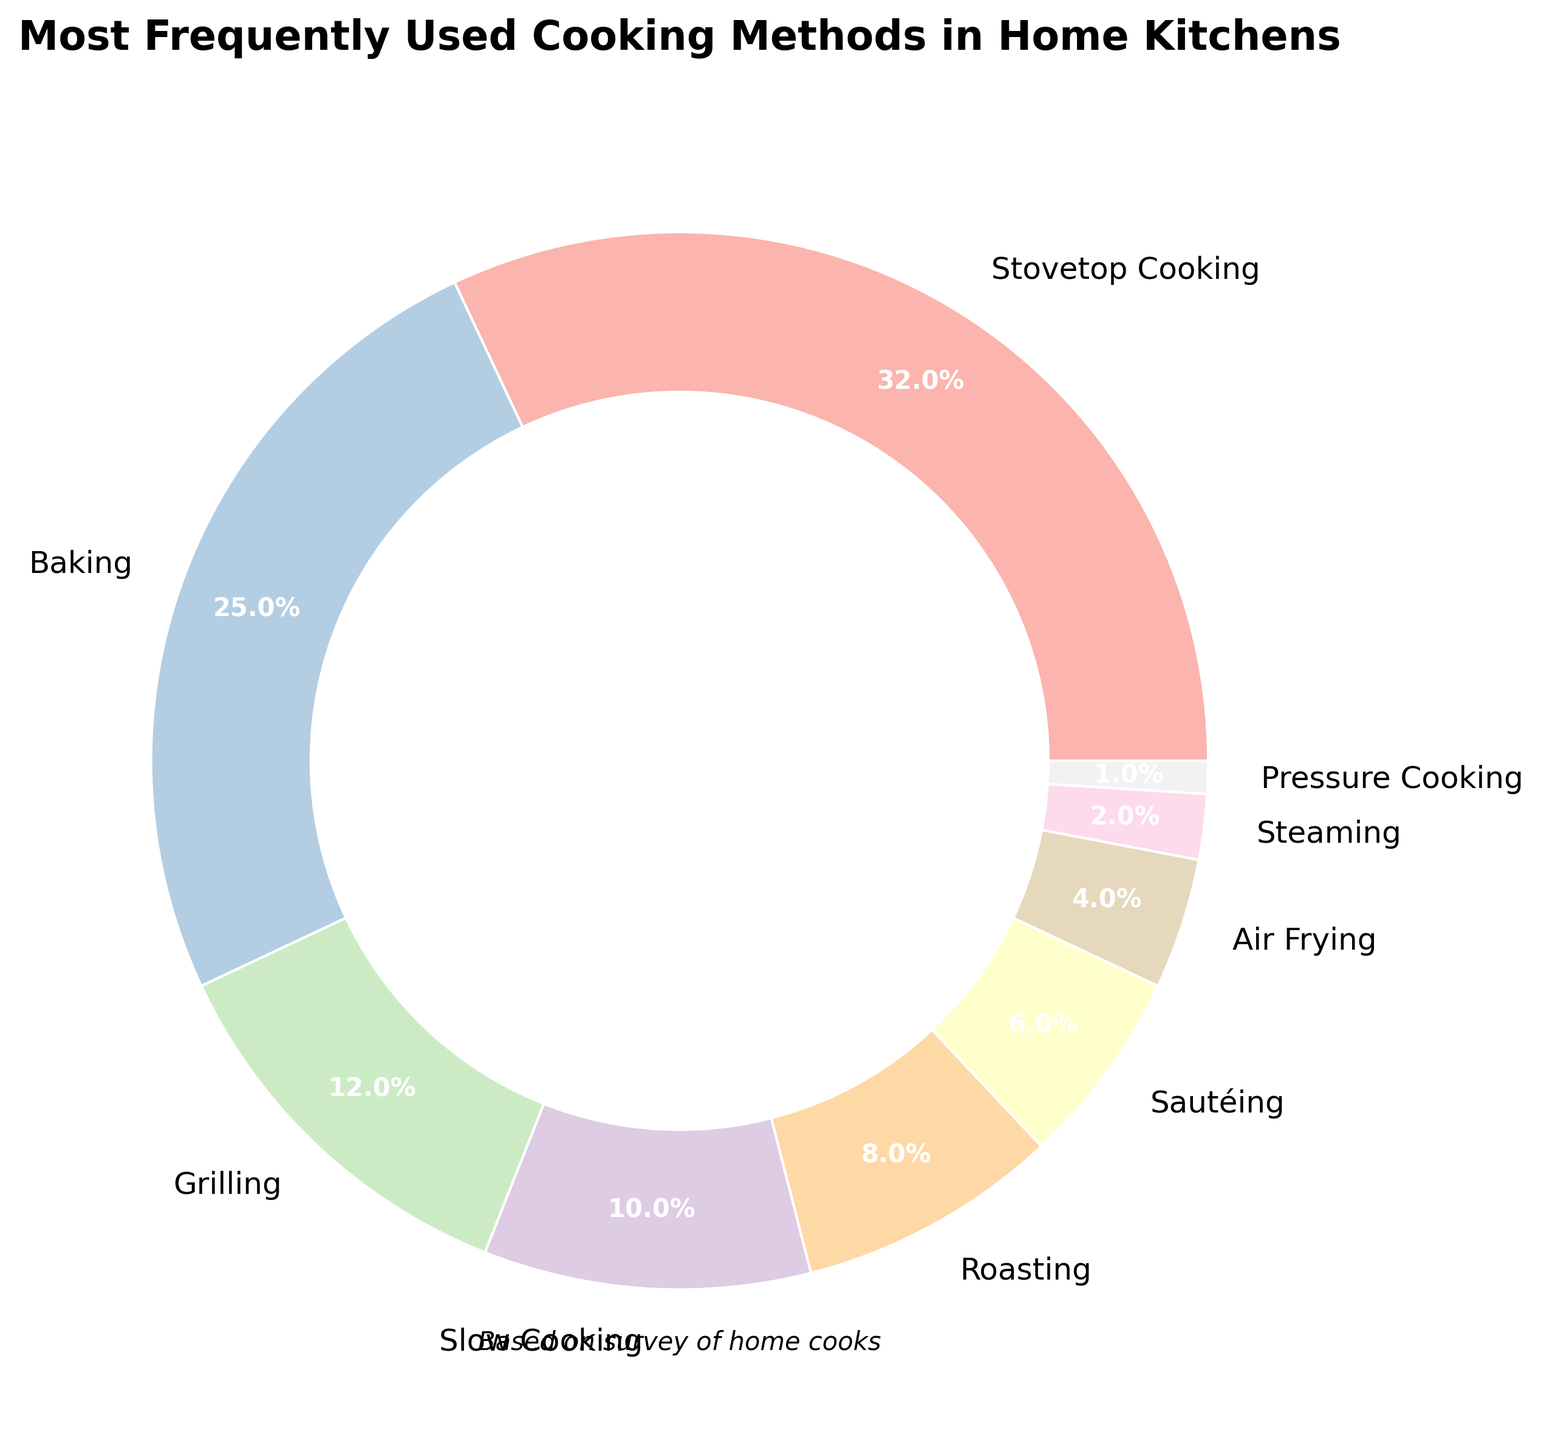What's the most frequently used cooking method in home kitchens? The pie chart shows different cooking methods with percentages. The largest segment in the chart represents Stovetop Cooking with 32%.
Answer: Stovetop Cooking What percentage of cooking methods is comprised by Grilling and Slow Cooking combined? According to the chart, Grilling is 12% and Slow Cooking is 10%. Adding these two percentages gives 12% + 10% = 22%.
Answer: 22% Which cooking method is used less frequently: Air Frying or Sautéing? The chart shows that Air Frying is 4% and Sautéing is 6%. Since 4% is less than 6%, Air Frying is used less frequently.
Answer: Air Frying How much more popular is Baking compared to Roasting? The chart shows Baking at 25% and Roasting at 8%. The difference can be calculated as 25% - 8% = 17%. Baking is 17% more popular than Roasting.
Answer: 17% What are the cooking methods with a usage percentage below 5%? The chart shows that Air Frying (4%), Steaming (2%), and Pressure Cooking (1%) all have usage percentages below 5%.
Answer: Air Frying, Steaming, Pressure Cooking Which cooking method occupies the smallest segment in the pie chart? The smallest segment in the pie chart represents the cooking method with the lowest percentage, which is Pressure Cooking at 1%.
Answer: Pressure Cooking Is the combined percentage of Roasting and Air Frying greater than that of Baking? Roasting is 8% and Air Frying is 4%, combined they make 12%, whereas Baking alone is 25%. Since 12% is less than 25%, the combined percentage of Roasting and Air Frying is not greater than that of Baking.
Answer: No Identify the cooking methods that together make up more than 50% of the total percentage. Stovetop Cooking (32%) and Baking (25%) add up to 32% + 25% = 57%, which is more than 50%. No other combination of methods exceeds 50%.
Answer: Stovetop Cooking, Baking Which cooking method’s percentage is exactly half of Slow Cooking’s percentage? Slow Cooking is 10%, so half of that is 10% / 2 = 5%. The chart shows no method with exactly 5%, but Sautéing is close at 6%.
Answer: None If Steaming and Pressure Cooking combined were tripled, would they surpass the percentage of Baking? Combine Steaming (2%) and Pressure Cooking (1%) to get 2% + 1% = 3%. Tripling this total gives 3% * 3 = 9%. Since Baking is 25%, 9% is less than 25%, so the tripled amount would not surpass Baking.
Answer: No 